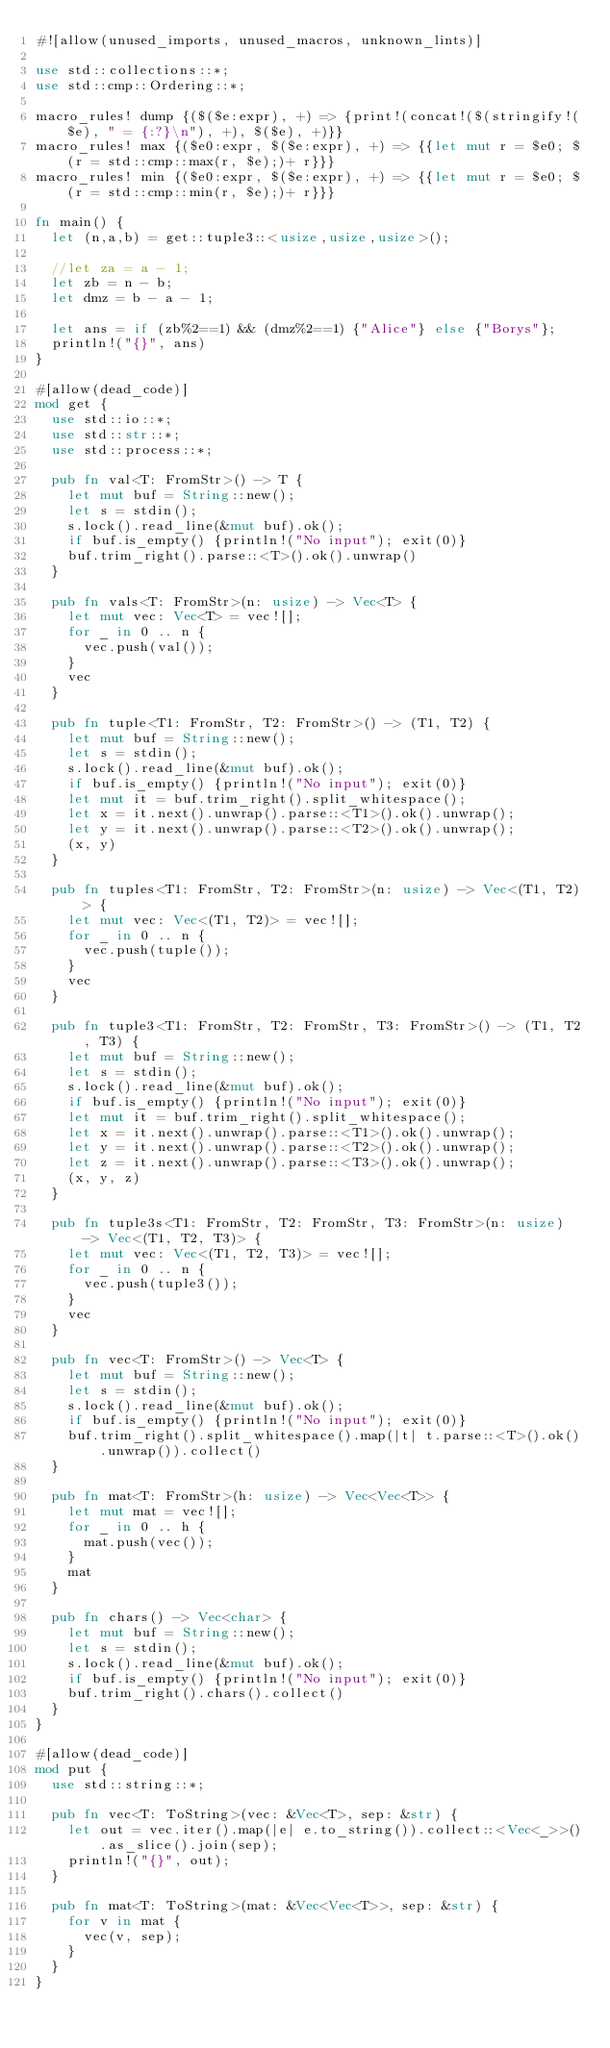<code> <loc_0><loc_0><loc_500><loc_500><_Rust_>#![allow(unused_imports, unused_macros, unknown_lints)]

use std::collections::*;
use std::cmp::Ordering::*;

macro_rules! dump {($($e:expr), +) => {print!(concat!($(stringify!($e), " = {:?}\n"), +), $($e), +)}}
macro_rules! max {($e0:expr, $($e:expr), +) => {{let mut r = $e0; $(r = std::cmp::max(r, $e);)+ r}}}
macro_rules! min {($e0:expr, $($e:expr), +) => {{let mut r = $e0; $(r = std::cmp::min(r, $e);)+ r}}}

fn main() {
  let (n,a,b) = get::tuple3::<usize,usize,usize>();

  //let za = a - 1;
  let zb = n - b;
  let dmz = b - a - 1;

  let ans = if (zb%2==1) && (dmz%2==1) {"Alice"} else {"Borys"};
  println!("{}", ans)
}

#[allow(dead_code)]
mod get {
  use std::io::*;
  use std::str::*;
  use std::process::*;

  pub fn val<T: FromStr>() -> T {
    let mut buf = String::new();
    let s = stdin();
    s.lock().read_line(&mut buf).ok();
    if buf.is_empty() {println!("No input"); exit(0)}
    buf.trim_right().parse::<T>().ok().unwrap()
  }

  pub fn vals<T: FromStr>(n: usize) -> Vec<T> {
    let mut vec: Vec<T> = vec![];
    for _ in 0 .. n {
      vec.push(val());
    }
    vec
  }

  pub fn tuple<T1: FromStr, T2: FromStr>() -> (T1, T2) {
    let mut buf = String::new();
    let s = stdin();
    s.lock().read_line(&mut buf).ok();
    if buf.is_empty() {println!("No input"); exit(0)}
    let mut it = buf.trim_right().split_whitespace();
    let x = it.next().unwrap().parse::<T1>().ok().unwrap();
    let y = it.next().unwrap().parse::<T2>().ok().unwrap();
    (x, y)
  }

  pub fn tuples<T1: FromStr, T2: FromStr>(n: usize) -> Vec<(T1, T2)> {
    let mut vec: Vec<(T1, T2)> = vec![];
    for _ in 0 .. n {
      vec.push(tuple());
    }
    vec
  }

  pub fn tuple3<T1: FromStr, T2: FromStr, T3: FromStr>() -> (T1, T2, T3) {
    let mut buf = String::new();
    let s = stdin();
    s.lock().read_line(&mut buf).ok();
    if buf.is_empty() {println!("No input"); exit(0)}
    let mut it = buf.trim_right().split_whitespace();
    let x = it.next().unwrap().parse::<T1>().ok().unwrap();
    let y = it.next().unwrap().parse::<T2>().ok().unwrap();
    let z = it.next().unwrap().parse::<T3>().ok().unwrap();
    (x, y, z)
  }

  pub fn tuple3s<T1: FromStr, T2: FromStr, T3: FromStr>(n: usize) -> Vec<(T1, T2, T3)> {
    let mut vec: Vec<(T1, T2, T3)> = vec![];
    for _ in 0 .. n {
      vec.push(tuple3());
    }
    vec
  }

  pub fn vec<T: FromStr>() -> Vec<T> {
    let mut buf = String::new();
    let s = stdin();
    s.lock().read_line(&mut buf).ok();
    if buf.is_empty() {println!("No input"); exit(0)}
    buf.trim_right().split_whitespace().map(|t| t.parse::<T>().ok().unwrap()).collect()
  }

  pub fn mat<T: FromStr>(h: usize) -> Vec<Vec<T>> {
    let mut mat = vec![];
    for _ in 0 .. h {
      mat.push(vec());
    }
    mat
  }

  pub fn chars() -> Vec<char> {
    let mut buf = String::new();
    let s = stdin();
    s.lock().read_line(&mut buf).ok();
    if buf.is_empty() {println!("No input"); exit(0)}
    buf.trim_right().chars().collect()
  }
}

#[allow(dead_code)]
mod put {
  use std::string::*;

  pub fn vec<T: ToString>(vec: &Vec<T>, sep: &str) {
    let out = vec.iter().map(|e| e.to_string()).collect::<Vec<_>>().as_slice().join(sep);
    println!("{}", out);
  }

  pub fn mat<T: ToString>(mat: &Vec<Vec<T>>, sep: &str) {
    for v in mat {
      vec(v, sep);
    }
  }
}</code> 